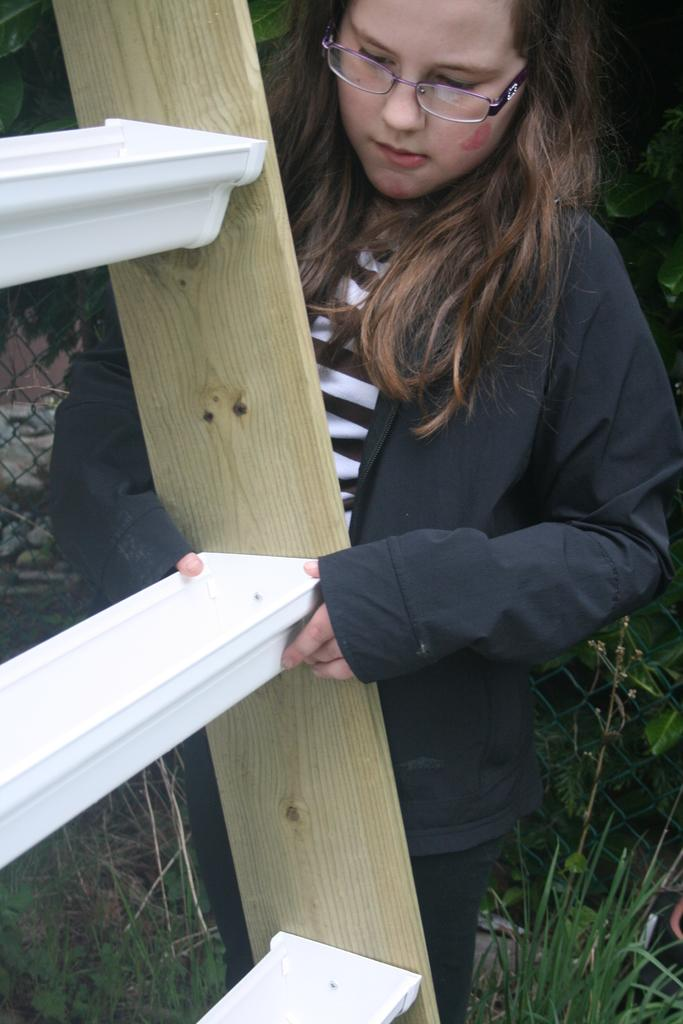Who is present in the image? There is a woman in the image. What is the woman wearing that is visible in the image? The woman is wearing spectacles. What object is in front of the woman? There is a ladder in front of the woman. What type of vegetation is beside the woman? There is grass beside the woman. What architectural feature can be seen in the image? There is a fence in the image. What type of farmer is working in the town depicted in the image? There is no farmer or town present in the image; it features a woman, a ladder, grass, and a fence. 